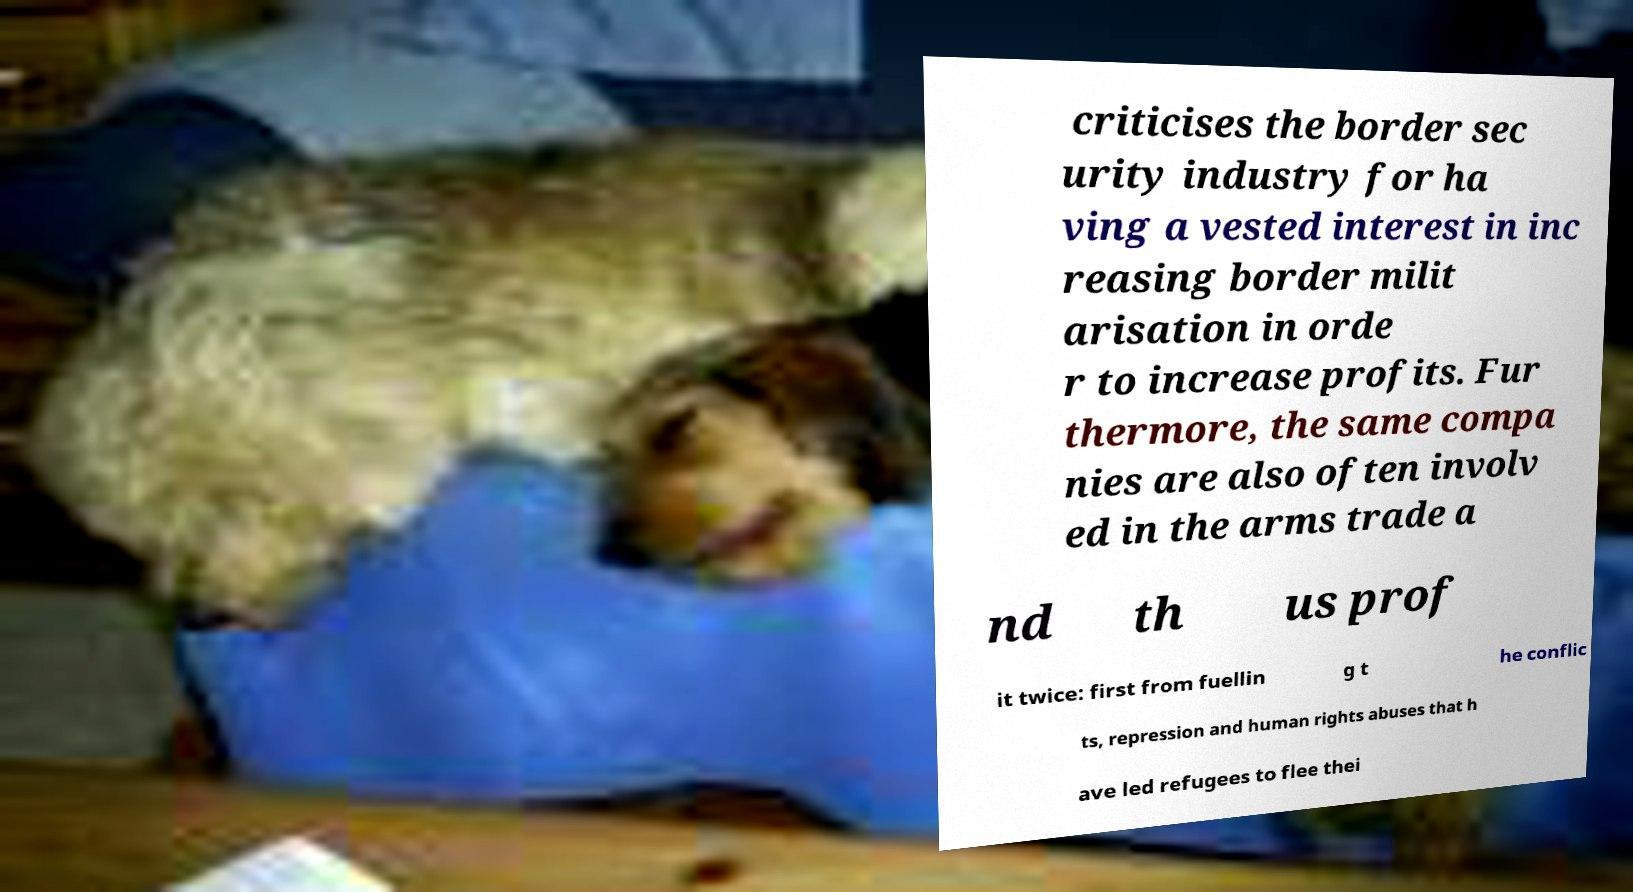Could you extract and type out the text from this image? criticises the border sec urity industry for ha ving a vested interest in inc reasing border milit arisation in orde r to increase profits. Fur thermore, the same compa nies are also often involv ed in the arms trade a nd th us prof it twice: first from fuellin g t he conflic ts, repression and human rights abuses that h ave led refugees to flee thei 